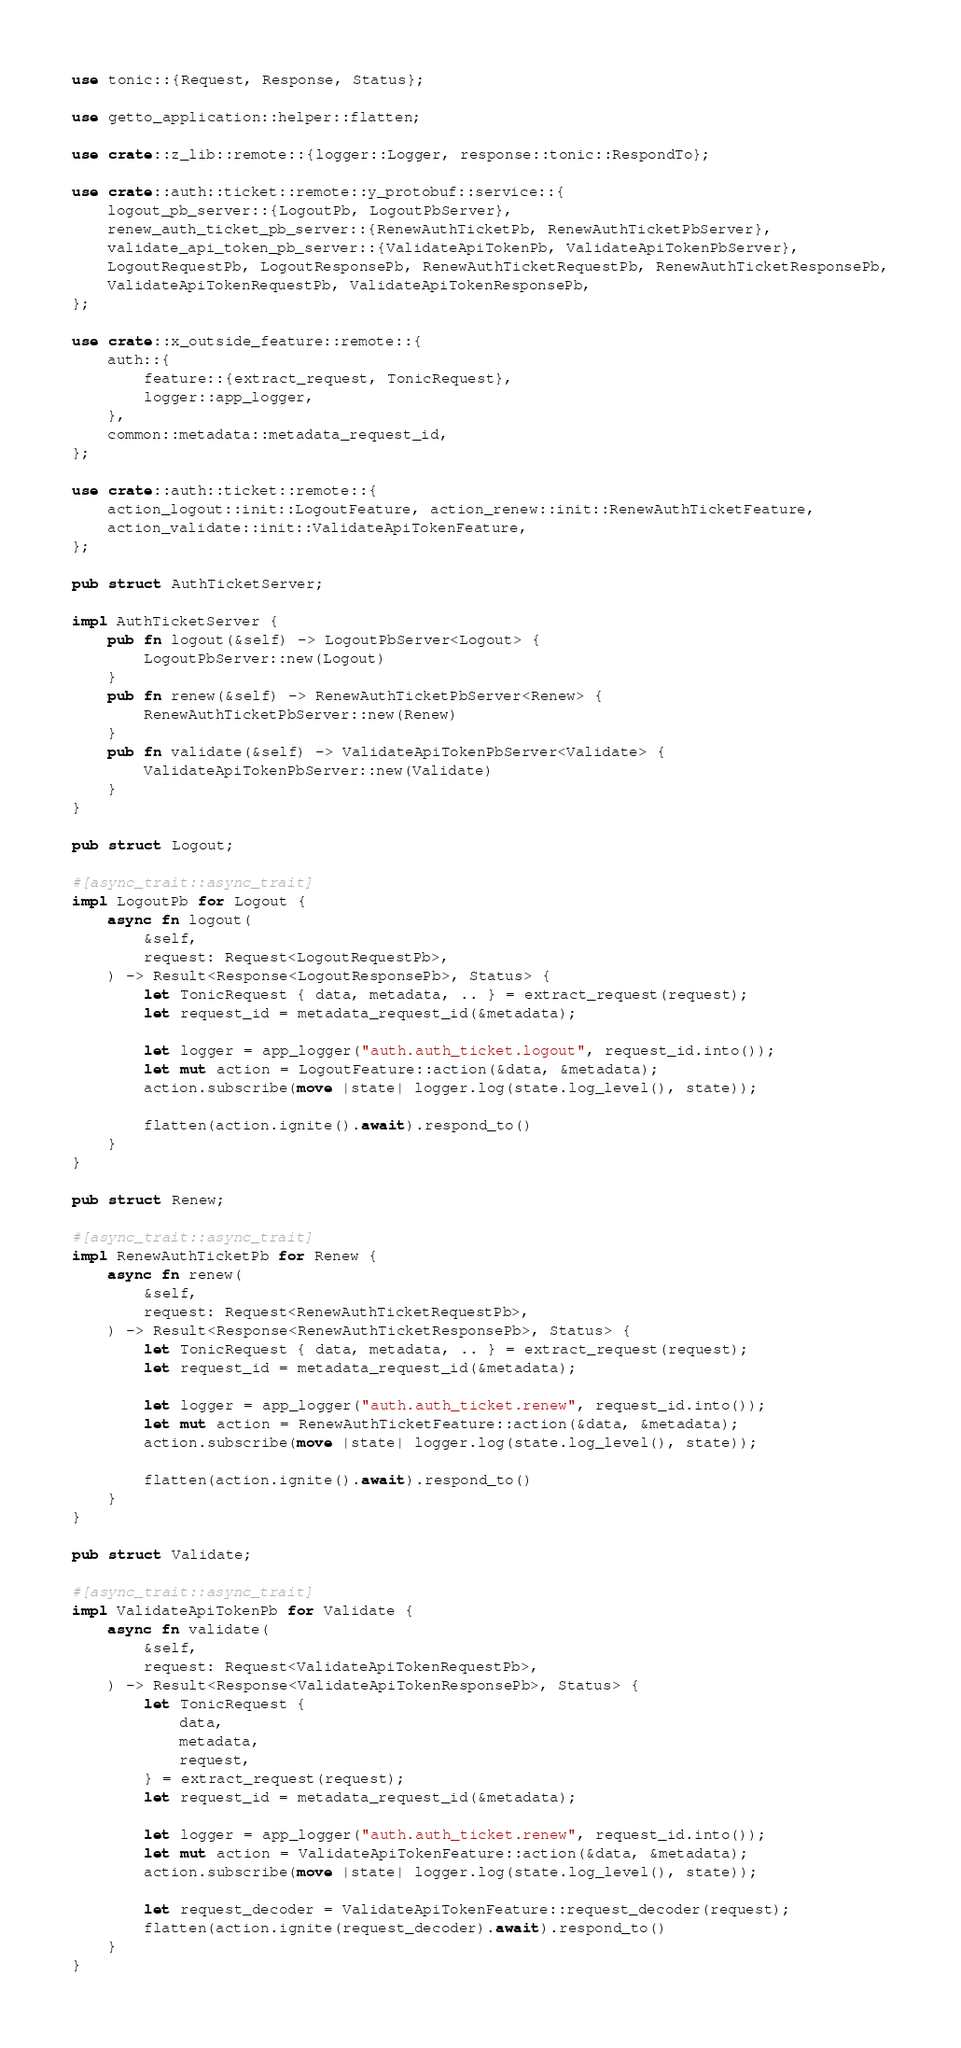Convert code to text. <code><loc_0><loc_0><loc_500><loc_500><_Rust_>use tonic::{Request, Response, Status};

use getto_application::helper::flatten;

use crate::z_lib::remote::{logger::Logger, response::tonic::RespondTo};

use crate::auth::ticket::remote::y_protobuf::service::{
    logout_pb_server::{LogoutPb, LogoutPbServer},
    renew_auth_ticket_pb_server::{RenewAuthTicketPb, RenewAuthTicketPbServer},
    validate_api_token_pb_server::{ValidateApiTokenPb, ValidateApiTokenPbServer},
    LogoutRequestPb, LogoutResponsePb, RenewAuthTicketRequestPb, RenewAuthTicketResponsePb,
    ValidateApiTokenRequestPb, ValidateApiTokenResponsePb,
};

use crate::x_outside_feature::remote::{
    auth::{
        feature::{extract_request, TonicRequest},
        logger::app_logger,
    },
    common::metadata::metadata_request_id,
};

use crate::auth::ticket::remote::{
    action_logout::init::LogoutFeature, action_renew::init::RenewAuthTicketFeature,
    action_validate::init::ValidateApiTokenFeature,
};

pub struct AuthTicketServer;

impl AuthTicketServer {
    pub fn logout(&self) -> LogoutPbServer<Logout> {
        LogoutPbServer::new(Logout)
    }
    pub fn renew(&self) -> RenewAuthTicketPbServer<Renew> {
        RenewAuthTicketPbServer::new(Renew)
    }
    pub fn validate(&self) -> ValidateApiTokenPbServer<Validate> {
        ValidateApiTokenPbServer::new(Validate)
    }
}

pub struct Logout;

#[async_trait::async_trait]
impl LogoutPb for Logout {
    async fn logout(
        &self,
        request: Request<LogoutRequestPb>,
    ) -> Result<Response<LogoutResponsePb>, Status> {
        let TonicRequest { data, metadata, .. } = extract_request(request);
        let request_id = metadata_request_id(&metadata);

        let logger = app_logger("auth.auth_ticket.logout", request_id.into());
        let mut action = LogoutFeature::action(&data, &metadata);
        action.subscribe(move |state| logger.log(state.log_level(), state));

        flatten(action.ignite().await).respond_to()
    }
}

pub struct Renew;

#[async_trait::async_trait]
impl RenewAuthTicketPb for Renew {
    async fn renew(
        &self,
        request: Request<RenewAuthTicketRequestPb>,
    ) -> Result<Response<RenewAuthTicketResponsePb>, Status> {
        let TonicRequest { data, metadata, .. } = extract_request(request);
        let request_id = metadata_request_id(&metadata);

        let logger = app_logger("auth.auth_ticket.renew", request_id.into());
        let mut action = RenewAuthTicketFeature::action(&data, &metadata);
        action.subscribe(move |state| logger.log(state.log_level(), state));

        flatten(action.ignite().await).respond_to()
    }
}

pub struct Validate;

#[async_trait::async_trait]
impl ValidateApiTokenPb for Validate {
    async fn validate(
        &self,
        request: Request<ValidateApiTokenRequestPb>,
    ) -> Result<Response<ValidateApiTokenResponsePb>, Status> {
        let TonicRequest {
            data,
            metadata,
            request,
        } = extract_request(request);
        let request_id = metadata_request_id(&metadata);

        let logger = app_logger("auth.auth_ticket.renew", request_id.into());
        let mut action = ValidateApiTokenFeature::action(&data, &metadata);
        action.subscribe(move |state| logger.log(state.log_level(), state));

        let request_decoder = ValidateApiTokenFeature::request_decoder(request);
        flatten(action.ignite(request_decoder).await).respond_to()
    }
}
</code> 